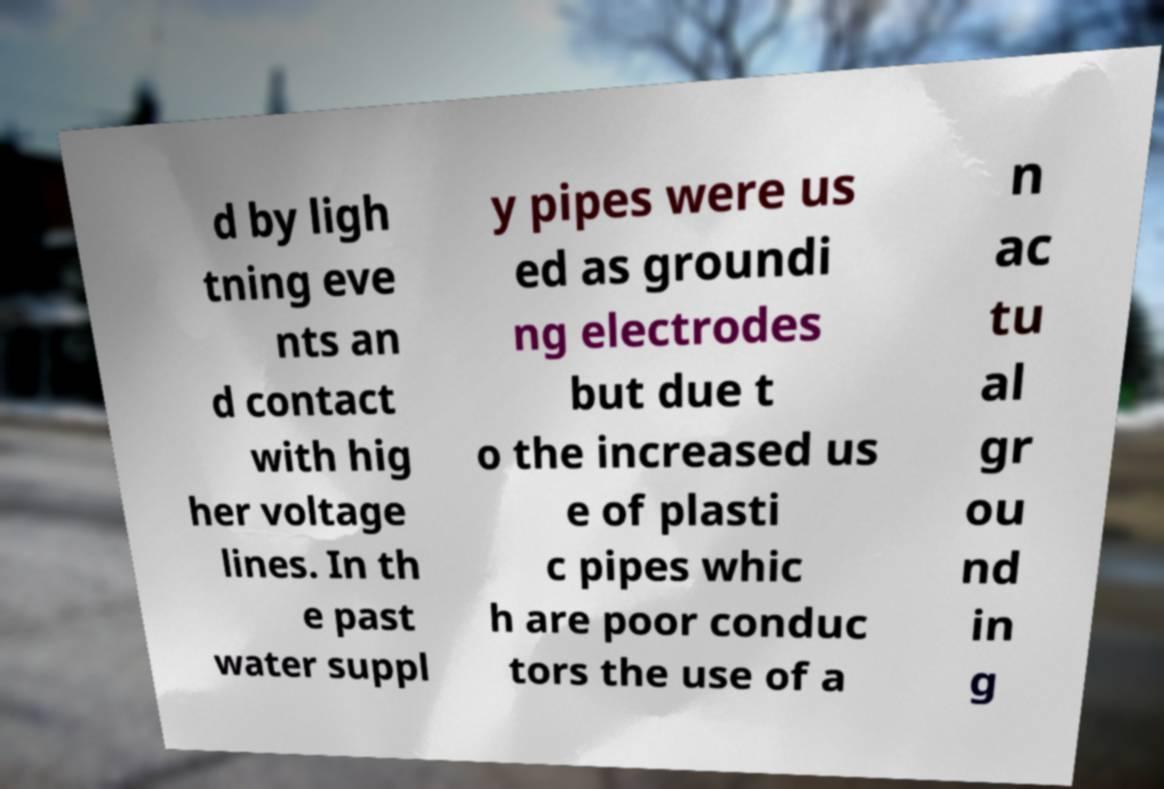Please identify and transcribe the text found in this image. d by ligh tning eve nts an d contact with hig her voltage lines. In th e past water suppl y pipes were us ed as groundi ng electrodes but due t o the increased us e of plasti c pipes whic h are poor conduc tors the use of a n ac tu al gr ou nd in g 